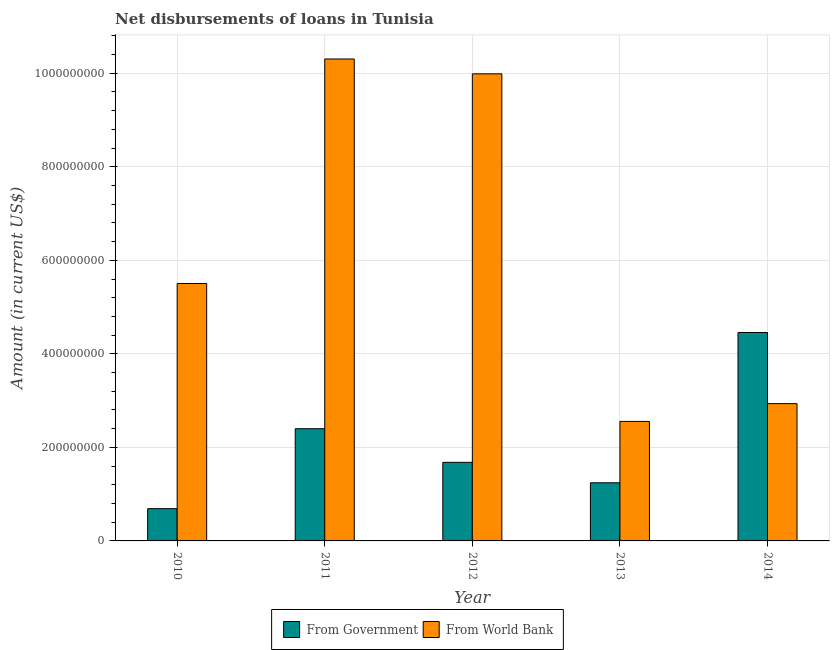Are the number of bars per tick equal to the number of legend labels?
Offer a very short reply. Yes. Are the number of bars on each tick of the X-axis equal?
Provide a short and direct response. Yes. How many bars are there on the 5th tick from the right?
Give a very brief answer. 2. In how many cases, is the number of bars for a given year not equal to the number of legend labels?
Your answer should be very brief. 0. What is the net disbursements of loan from world bank in 2011?
Ensure brevity in your answer.  1.03e+09. Across all years, what is the maximum net disbursements of loan from government?
Offer a very short reply. 4.46e+08. Across all years, what is the minimum net disbursements of loan from world bank?
Provide a succinct answer. 2.56e+08. In which year was the net disbursements of loan from government maximum?
Ensure brevity in your answer.  2014. What is the total net disbursements of loan from world bank in the graph?
Your response must be concise. 3.13e+09. What is the difference between the net disbursements of loan from world bank in 2011 and that in 2012?
Ensure brevity in your answer.  3.18e+07. What is the difference between the net disbursements of loan from government in 2010 and the net disbursements of loan from world bank in 2013?
Your answer should be compact. -5.53e+07. What is the average net disbursements of loan from world bank per year?
Make the answer very short. 6.26e+08. In how many years, is the net disbursements of loan from government greater than 920000000 US$?
Offer a very short reply. 0. What is the ratio of the net disbursements of loan from government in 2010 to that in 2014?
Make the answer very short. 0.15. Is the difference between the net disbursements of loan from government in 2011 and 2012 greater than the difference between the net disbursements of loan from world bank in 2011 and 2012?
Make the answer very short. No. What is the difference between the highest and the second highest net disbursements of loan from government?
Offer a terse response. 2.06e+08. What is the difference between the highest and the lowest net disbursements of loan from world bank?
Your response must be concise. 7.75e+08. In how many years, is the net disbursements of loan from world bank greater than the average net disbursements of loan from world bank taken over all years?
Ensure brevity in your answer.  2. What does the 2nd bar from the left in 2012 represents?
Offer a terse response. From World Bank. What does the 2nd bar from the right in 2010 represents?
Your answer should be compact. From Government. How many bars are there?
Provide a short and direct response. 10. Are all the bars in the graph horizontal?
Provide a short and direct response. No. How many years are there in the graph?
Offer a terse response. 5. What is the difference between two consecutive major ticks on the Y-axis?
Your answer should be compact. 2.00e+08. Are the values on the major ticks of Y-axis written in scientific E-notation?
Make the answer very short. No. Does the graph contain any zero values?
Give a very brief answer. No. Does the graph contain grids?
Your answer should be very brief. Yes. Where does the legend appear in the graph?
Provide a succinct answer. Bottom center. What is the title of the graph?
Your response must be concise. Net disbursements of loans in Tunisia. What is the label or title of the X-axis?
Your answer should be very brief. Year. What is the Amount (in current US$) of From Government in 2010?
Offer a very short reply. 6.90e+07. What is the Amount (in current US$) of From World Bank in 2010?
Your response must be concise. 5.50e+08. What is the Amount (in current US$) of From Government in 2011?
Give a very brief answer. 2.40e+08. What is the Amount (in current US$) of From World Bank in 2011?
Your answer should be very brief. 1.03e+09. What is the Amount (in current US$) of From Government in 2012?
Provide a short and direct response. 1.68e+08. What is the Amount (in current US$) in From World Bank in 2012?
Keep it short and to the point. 9.99e+08. What is the Amount (in current US$) of From Government in 2013?
Provide a succinct answer. 1.24e+08. What is the Amount (in current US$) of From World Bank in 2013?
Make the answer very short. 2.56e+08. What is the Amount (in current US$) in From Government in 2014?
Offer a terse response. 4.46e+08. What is the Amount (in current US$) in From World Bank in 2014?
Give a very brief answer. 2.94e+08. Across all years, what is the maximum Amount (in current US$) in From Government?
Keep it short and to the point. 4.46e+08. Across all years, what is the maximum Amount (in current US$) in From World Bank?
Offer a very short reply. 1.03e+09. Across all years, what is the minimum Amount (in current US$) of From Government?
Offer a very short reply. 6.90e+07. Across all years, what is the minimum Amount (in current US$) of From World Bank?
Provide a short and direct response. 2.56e+08. What is the total Amount (in current US$) of From Government in the graph?
Ensure brevity in your answer.  1.05e+09. What is the total Amount (in current US$) of From World Bank in the graph?
Make the answer very short. 3.13e+09. What is the difference between the Amount (in current US$) in From Government in 2010 and that in 2011?
Provide a succinct answer. -1.71e+08. What is the difference between the Amount (in current US$) in From World Bank in 2010 and that in 2011?
Provide a succinct answer. -4.80e+08. What is the difference between the Amount (in current US$) in From Government in 2010 and that in 2012?
Make the answer very short. -9.91e+07. What is the difference between the Amount (in current US$) in From World Bank in 2010 and that in 2012?
Your answer should be very brief. -4.48e+08. What is the difference between the Amount (in current US$) in From Government in 2010 and that in 2013?
Ensure brevity in your answer.  -5.53e+07. What is the difference between the Amount (in current US$) of From World Bank in 2010 and that in 2013?
Your answer should be very brief. 2.95e+08. What is the difference between the Amount (in current US$) in From Government in 2010 and that in 2014?
Your answer should be compact. -3.77e+08. What is the difference between the Amount (in current US$) in From World Bank in 2010 and that in 2014?
Make the answer very short. 2.57e+08. What is the difference between the Amount (in current US$) of From Government in 2011 and that in 2012?
Your response must be concise. 7.19e+07. What is the difference between the Amount (in current US$) of From World Bank in 2011 and that in 2012?
Provide a short and direct response. 3.18e+07. What is the difference between the Amount (in current US$) in From Government in 2011 and that in 2013?
Ensure brevity in your answer.  1.16e+08. What is the difference between the Amount (in current US$) in From World Bank in 2011 and that in 2013?
Make the answer very short. 7.75e+08. What is the difference between the Amount (in current US$) in From Government in 2011 and that in 2014?
Your answer should be compact. -2.06e+08. What is the difference between the Amount (in current US$) in From World Bank in 2011 and that in 2014?
Your answer should be very brief. 7.37e+08. What is the difference between the Amount (in current US$) of From Government in 2012 and that in 2013?
Offer a very short reply. 4.38e+07. What is the difference between the Amount (in current US$) in From World Bank in 2012 and that in 2013?
Provide a short and direct response. 7.43e+08. What is the difference between the Amount (in current US$) of From Government in 2012 and that in 2014?
Provide a succinct answer. -2.78e+08. What is the difference between the Amount (in current US$) of From World Bank in 2012 and that in 2014?
Make the answer very short. 7.05e+08. What is the difference between the Amount (in current US$) in From Government in 2013 and that in 2014?
Give a very brief answer. -3.21e+08. What is the difference between the Amount (in current US$) in From World Bank in 2013 and that in 2014?
Provide a succinct answer. -3.80e+07. What is the difference between the Amount (in current US$) of From Government in 2010 and the Amount (in current US$) of From World Bank in 2011?
Give a very brief answer. -9.62e+08. What is the difference between the Amount (in current US$) in From Government in 2010 and the Amount (in current US$) in From World Bank in 2012?
Your answer should be compact. -9.30e+08. What is the difference between the Amount (in current US$) in From Government in 2010 and the Amount (in current US$) in From World Bank in 2013?
Provide a short and direct response. -1.87e+08. What is the difference between the Amount (in current US$) of From Government in 2010 and the Amount (in current US$) of From World Bank in 2014?
Make the answer very short. -2.25e+08. What is the difference between the Amount (in current US$) in From Government in 2011 and the Amount (in current US$) in From World Bank in 2012?
Offer a terse response. -7.59e+08. What is the difference between the Amount (in current US$) of From Government in 2011 and the Amount (in current US$) of From World Bank in 2013?
Provide a short and direct response. -1.56e+07. What is the difference between the Amount (in current US$) of From Government in 2011 and the Amount (in current US$) of From World Bank in 2014?
Ensure brevity in your answer.  -5.36e+07. What is the difference between the Amount (in current US$) of From Government in 2012 and the Amount (in current US$) of From World Bank in 2013?
Keep it short and to the point. -8.75e+07. What is the difference between the Amount (in current US$) of From Government in 2012 and the Amount (in current US$) of From World Bank in 2014?
Your answer should be compact. -1.26e+08. What is the difference between the Amount (in current US$) of From Government in 2013 and the Amount (in current US$) of From World Bank in 2014?
Offer a terse response. -1.69e+08. What is the average Amount (in current US$) in From Government per year?
Keep it short and to the point. 2.09e+08. What is the average Amount (in current US$) of From World Bank per year?
Your answer should be compact. 6.26e+08. In the year 2010, what is the difference between the Amount (in current US$) in From Government and Amount (in current US$) in From World Bank?
Give a very brief answer. -4.81e+08. In the year 2011, what is the difference between the Amount (in current US$) in From Government and Amount (in current US$) in From World Bank?
Make the answer very short. -7.91e+08. In the year 2012, what is the difference between the Amount (in current US$) in From Government and Amount (in current US$) in From World Bank?
Offer a very short reply. -8.31e+08. In the year 2013, what is the difference between the Amount (in current US$) of From Government and Amount (in current US$) of From World Bank?
Keep it short and to the point. -1.31e+08. In the year 2014, what is the difference between the Amount (in current US$) of From Government and Amount (in current US$) of From World Bank?
Give a very brief answer. 1.52e+08. What is the ratio of the Amount (in current US$) in From Government in 2010 to that in 2011?
Your answer should be compact. 0.29. What is the ratio of the Amount (in current US$) of From World Bank in 2010 to that in 2011?
Your answer should be very brief. 0.53. What is the ratio of the Amount (in current US$) in From Government in 2010 to that in 2012?
Provide a short and direct response. 0.41. What is the ratio of the Amount (in current US$) of From World Bank in 2010 to that in 2012?
Provide a short and direct response. 0.55. What is the ratio of the Amount (in current US$) in From Government in 2010 to that in 2013?
Your answer should be compact. 0.56. What is the ratio of the Amount (in current US$) of From World Bank in 2010 to that in 2013?
Your answer should be very brief. 2.15. What is the ratio of the Amount (in current US$) of From Government in 2010 to that in 2014?
Offer a terse response. 0.15. What is the ratio of the Amount (in current US$) in From World Bank in 2010 to that in 2014?
Keep it short and to the point. 1.88. What is the ratio of the Amount (in current US$) of From Government in 2011 to that in 2012?
Offer a terse response. 1.43. What is the ratio of the Amount (in current US$) in From World Bank in 2011 to that in 2012?
Your answer should be very brief. 1.03. What is the ratio of the Amount (in current US$) of From Government in 2011 to that in 2013?
Your response must be concise. 1.93. What is the ratio of the Amount (in current US$) in From World Bank in 2011 to that in 2013?
Ensure brevity in your answer.  4.03. What is the ratio of the Amount (in current US$) of From Government in 2011 to that in 2014?
Offer a terse response. 0.54. What is the ratio of the Amount (in current US$) in From World Bank in 2011 to that in 2014?
Ensure brevity in your answer.  3.51. What is the ratio of the Amount (in current US$) of From Government in 2012 to that in 2013?
Keep it short and to the point. 1.35. What is the ratio of the Amount (in current US$) in From World Bank in 2012 to that in 2013?
Offer a terse response. 3.91. What is the ratio of the Amount (in current US$) of From Government in 2012 to that in 2014?
Ensure brevity in your answer.  0.38. What is the ratio of the Amount (in current US$) of From World Bank in 2012 to that in 2014?
Keep it short and to the point. 3.4. What is the ratio of the Amount (in current US$) in From Government in 2013 to that in 2014?
Make the answer very short. 0.28. What is the ratio of the Amount (in current US$) of From World Bank in 2013 to that in 2014?
Your response must be concise. 0.87. What is the difference between the highest and the second highest Amount (in current US$) in From Government?
Ensure brevity in your answer.  2.06e+08. What is the difference between the highest and the second highest Amount (in current US$) in From World Bank?
Give a very brief answer. 3.18e+07. What is the difference between the highest and the lowest Amount (in current US$) in From Government?
Offer a very short reply. 3.77e+08. What is the difference between the highest and the lowest Amount (in current US$) of From World Bank?
Provide a short and direct response. 7.75e+08. 